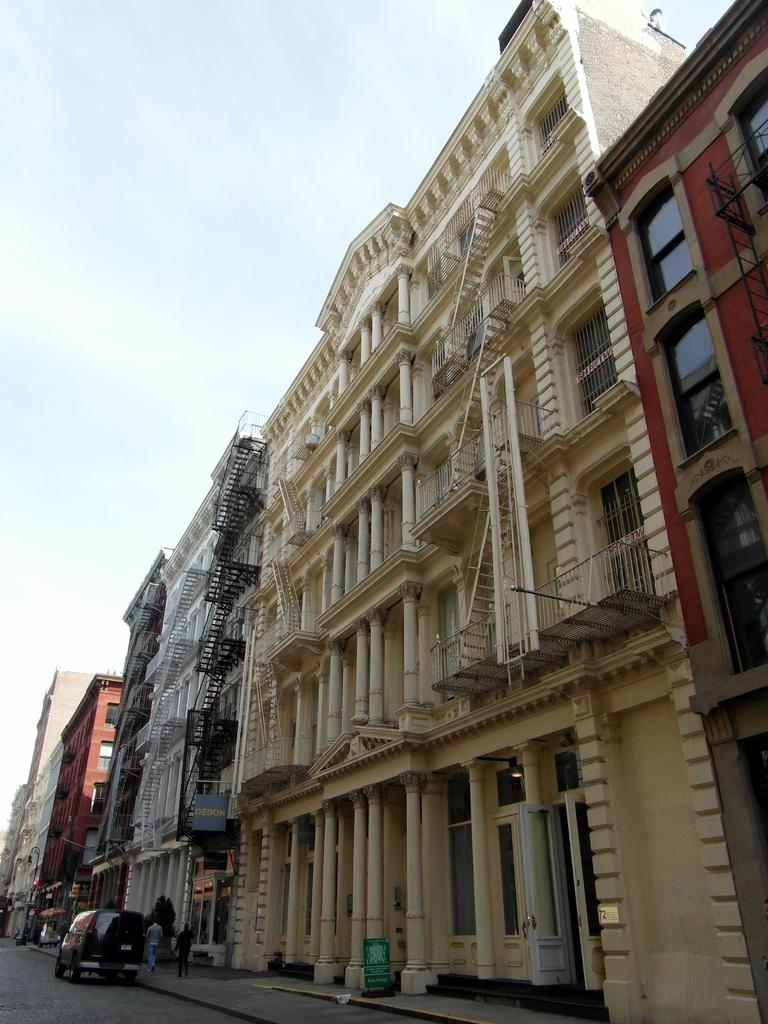What is located at the bottom of the image? There is a car, a road, a footpath, plants, and people at the bottom of the image. What can be seen on the ground at the bottom of the image? There is a road, a footpath, plants, and people at the bottom of the image. What type of structure is present at the bottom of the image? There is a board at the bottom of the image. What is visible in the middle of the image? There are buildings in the middle of the image. What is visible at the top of the image? There is sky visible at the top of the image. Can you tell me how many potatoes are being carried by the people in the image? There is no mention of potatoes in the image; the people are not carrying any potatoes. Is there a baby in the image? There is no mention of a baby in the image; no baby is present. 